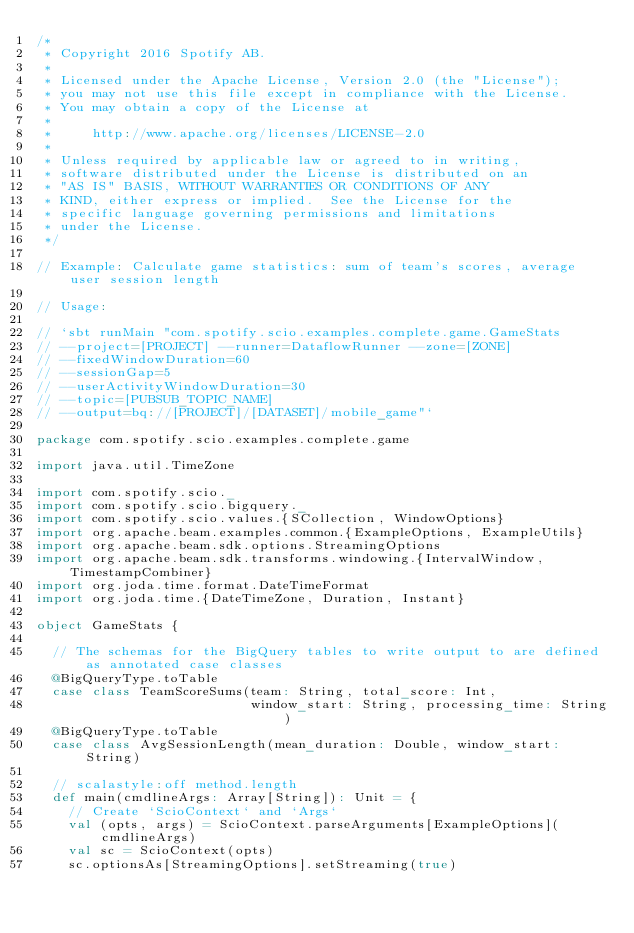<code> <loc_0><loc_0><loc_500><loc_500><_Scala_>/*
 * Copyright 2016 Spotify AB.
 *
 * Licensed under the Apache License, Version 2.0 (the "License");
 * you may not use this file except in compliance with the License.
 * You may obtain a copy of the License at
 *
 *     http://www.apache.org/licenses/LICENSE-2.0
 *
 * Unless required by applicable law or agreed to in writing,
 * software distributed under the License is distributed on an
 * "AS IS" BASIS, WITHOUT WARRANTIES OR CONDITIONS OF ANY
 * KIND, either express or implied.  See the License for the
 * specific language governing permissions and limitations
 * under the License.
 */

// Example: Calculate game statistics: sum of team's scores, average user session length

// Usage:

// `sbt runMain "com.spotify.scio.examples.complete.game.GameStats
// --project=[PROJECT] --runner=DataflowRunner --zone=[ZONE]
// --fixedWindowDuration=60
// --sessionGap=5
// --userActivityWindowDuration=30
// --topic=[PUBSUB_TOPIC_NAME]
// --output=bq://[PROJECT]/[DATASET]/mobile_game"`

package com.spotify.scio.examples.complete.game

import java.util.TimeZone

import com.spotify.scio._
import com.spotify.scio.bigquery._
import com.spotify.scio.values.{SCollection, WindowOptions}
import org.apache.beam.examples.common.{ExampleOptions, ExampleUtils}
import org.apache.beam.sdk.options.StreamingOptions
import org.apache.beam.sdk.transforms.windowing.{IntervalWindow, TimestampCombiner}
import org.joda.time.format.DateTimeFormat
import org.joda.time.{DateTimeZone, Duration, Instant}

object GameStats {

  // The schemas for the BigQuery tables to write output to are defined as annotated case classes
  @BigQueryType.toTable
  case class TeamScoreSums(team: String, total_score: Int,
                           window_start: String, processing_time: String)
  @BigQueryType.toTable
  case class AvgSessionLength(mean_duration: Double, window_start: String)

  // scalastyle:off method.length
  def main(cmdlineArgs: Array[String]): Unit = {
    // Create `ScioContext` and `Args`
    val (opts, args) = ScioContext.parseArguments[ExampleOptions](cmdlineArgs)
    val sc = ScioContext(opts)
    sc.optionsAs[StreamingOptions].setStreaming(true)</code> 